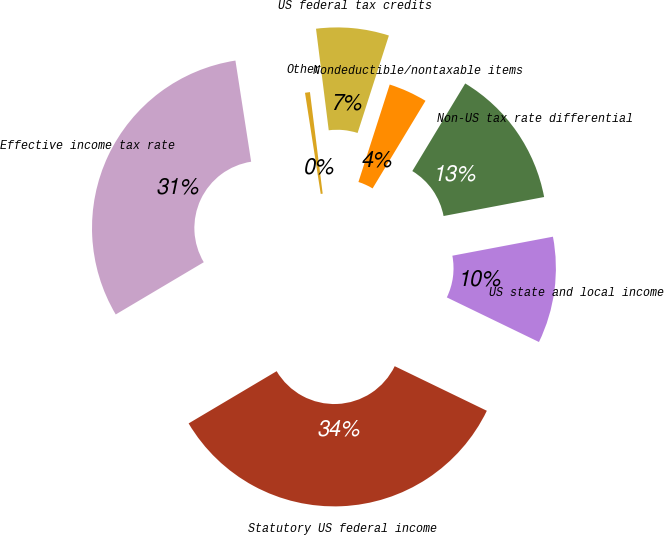<chart> <loc_0><loc_0><loc_500><loc_500><pie_chart><fcel>Statutory US federal income<fcel>US state and local income<fcel>Non-US tax rate differential<fcel>Nondeductible/nontaxable items<fcel>US federal tax credits<fcel>Other<fcel>Effective income tax rate<nl><fcel>34.3%<fcel>10.15%<fcel>13.38%<fcel>3.7%<fcel>6.93%<fcel>0.47%<fcel>31.07%<nl></chart> 